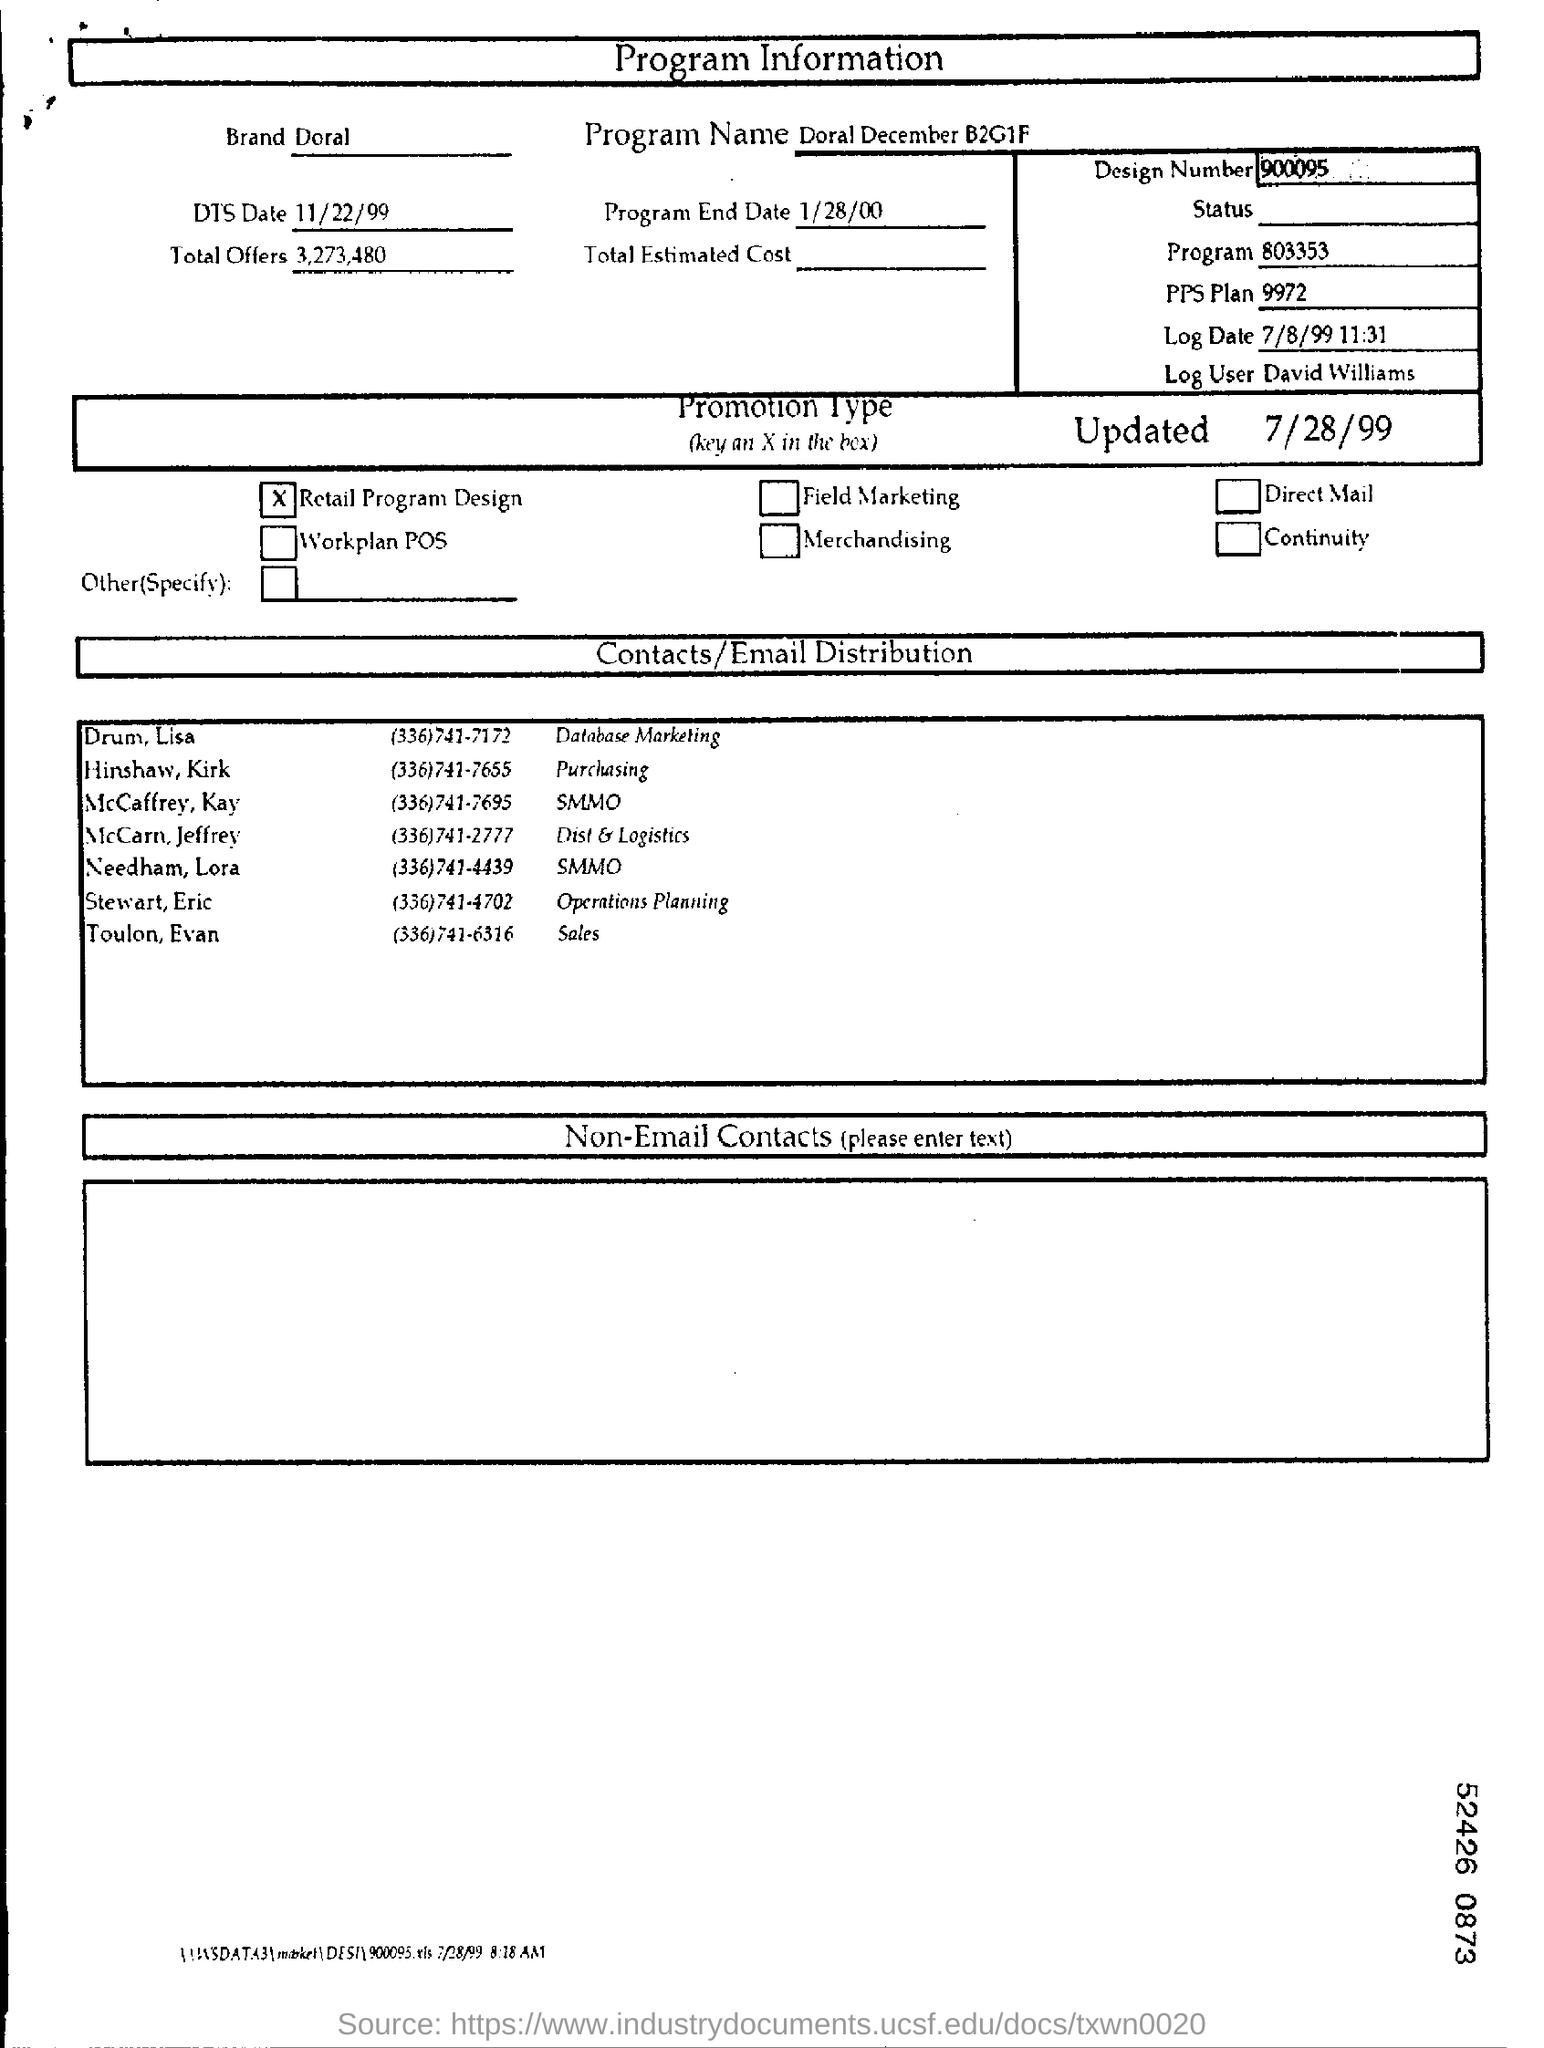Indicate a few pertinent items in this graphic. The log user is David Williams. There were 3,273,480 total offers. What is the date of DTS, which is November 22nd, 1999. The promotion type is retail program design. 